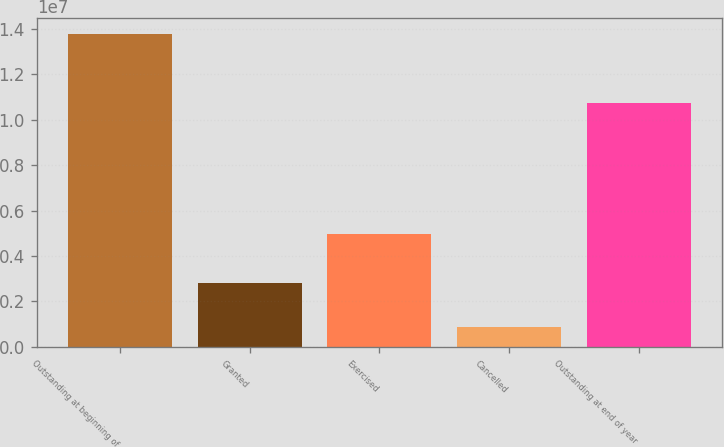<chart> <loc_0><loc_0><loc_500><loc_500><bar_chart><fcel>Outstanding at beginning of<fcel>Granted<fcel>Exercised<fcel>Cancelled<fcel>Outstanding at end of year<nl><fcel>1.3778e+07<fcel>2.79442e+06<fcel>4.9504e+06<fcel>889886<fcel>1.07321e+07<nl></chart> 